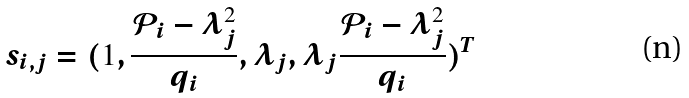Convert formula to latex. <formula><loc_0><loc_0><loc_500><loc_500>s _ { i , j } = ( 1 , \frac { \mathcal { P } _ { i } - \lambda _ { j } ^ { 2 } } { q _ { i } } , \lambda _ { j } , \lambda _ { j } \frac { \mathcal { P } _ { i } - \lambda _ { j } ^ { 2 } } { q _ { i } } ) ^ { T }</formula> 